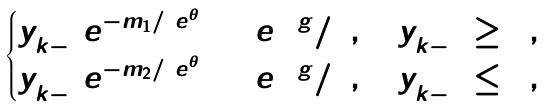<formula> <loc_0><loc_0><loc_500><loc_500>\begin{cases} y _ { k - 1 } ^ { + } e ^ { - m _ { 1 } / \ e ^ { \theta } } + \ e ^ { 2 \ g } / 5 , \quad y _ { k - 1 } ^ { + } \geq 0 , \\ y _ { k - 1 } ^ { + } e ^ { - m _ { 2 } / \ e ^ { \theta } } + \ e ^ { 2 \ g } / 5 , \quad y _ { k - 1 } ^ { + } \leq 0 , \end{cases}</formula> 